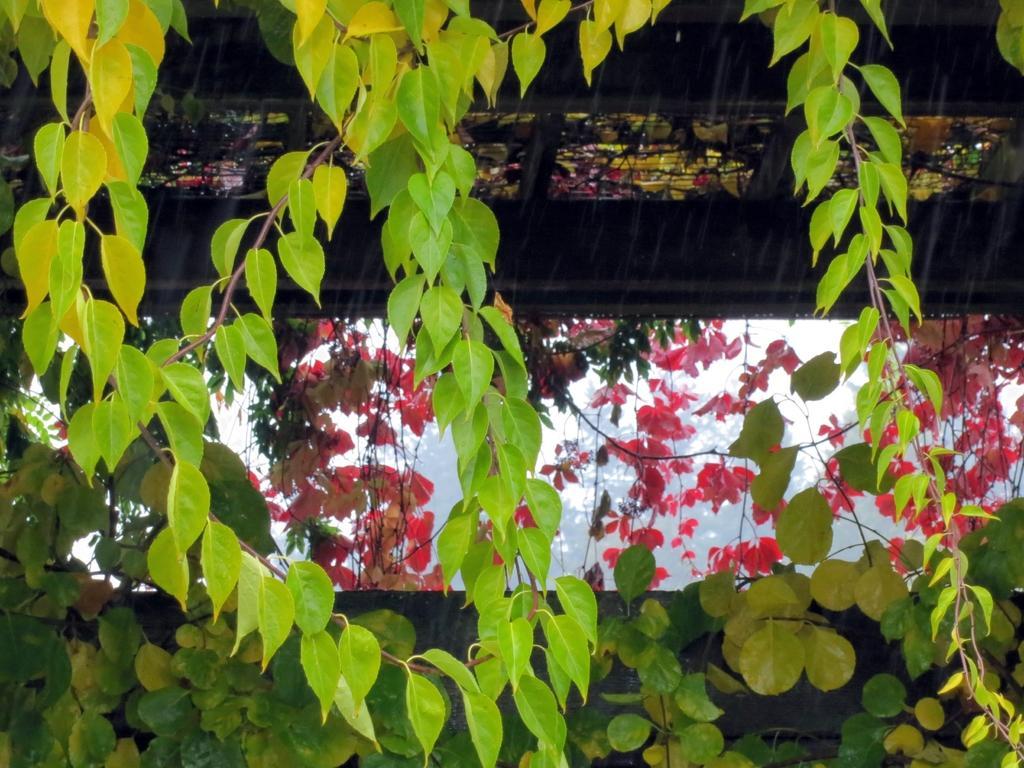In one or two sentences, can you explain what this image depicts? In this image we can see leaves in green and pink color. 